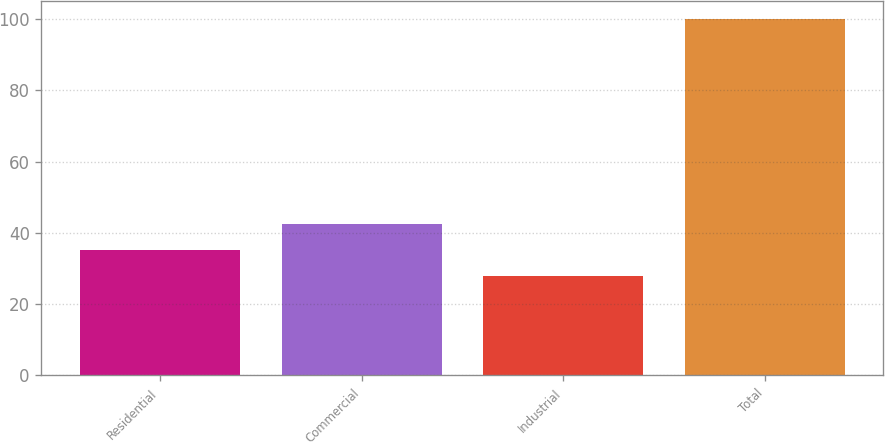Convert chart to OTSL. <chart><loc_0><loc_0><loc_500><loc_500><bar_chart><fcel>Residential<fcel>Commercial<fcel>Industrial<fcel>Total<nl><fcel>35.2<fcel>42.4<fcel>28<fcel>100<nl></chart> 